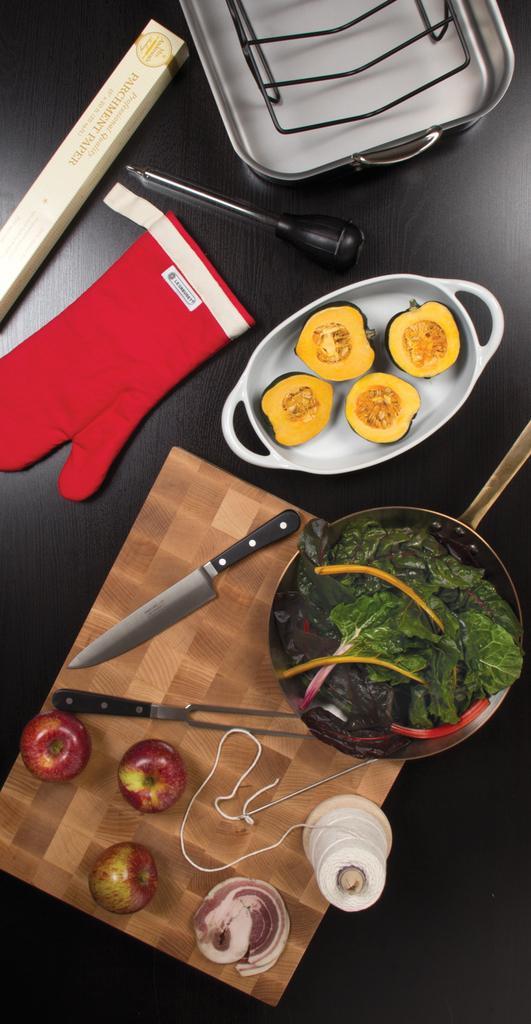Please provide a concise description of this image. In this image there are different types of fruits and vegetables and there is also a knife and red color glove and at the bottom of the image there is a needle and thread and at the left side of the image there are three apples and there is a pan and at the top of the image there is a dish 